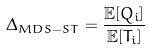<formula> <loc_0><loc_0><loc_500><loc_500>\Delta _ { M D S - S T } = \frac { \mathbb { E } [ Q _ { i } ] } { \mathbb { E } [ T _ { i } ] }</formula> 